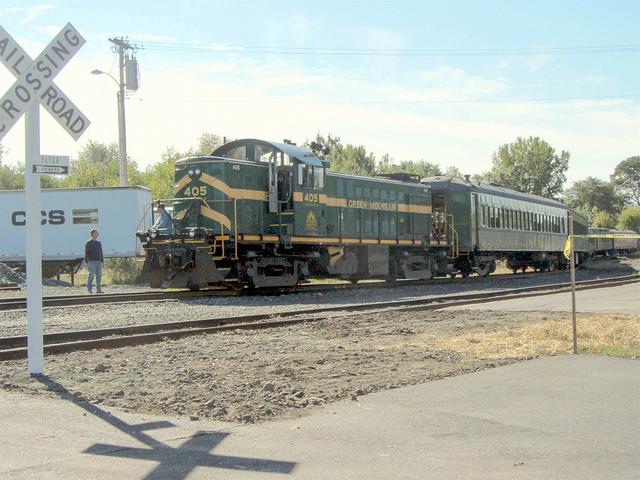What number is displayed on the front of the train?
Short answer required. 405. How many rails do you see?
Give a very brief answer. 2. What number is on the train?
Be succinct. 405. Should cars stop before the sign right now?
Quick response, please. Yes. 